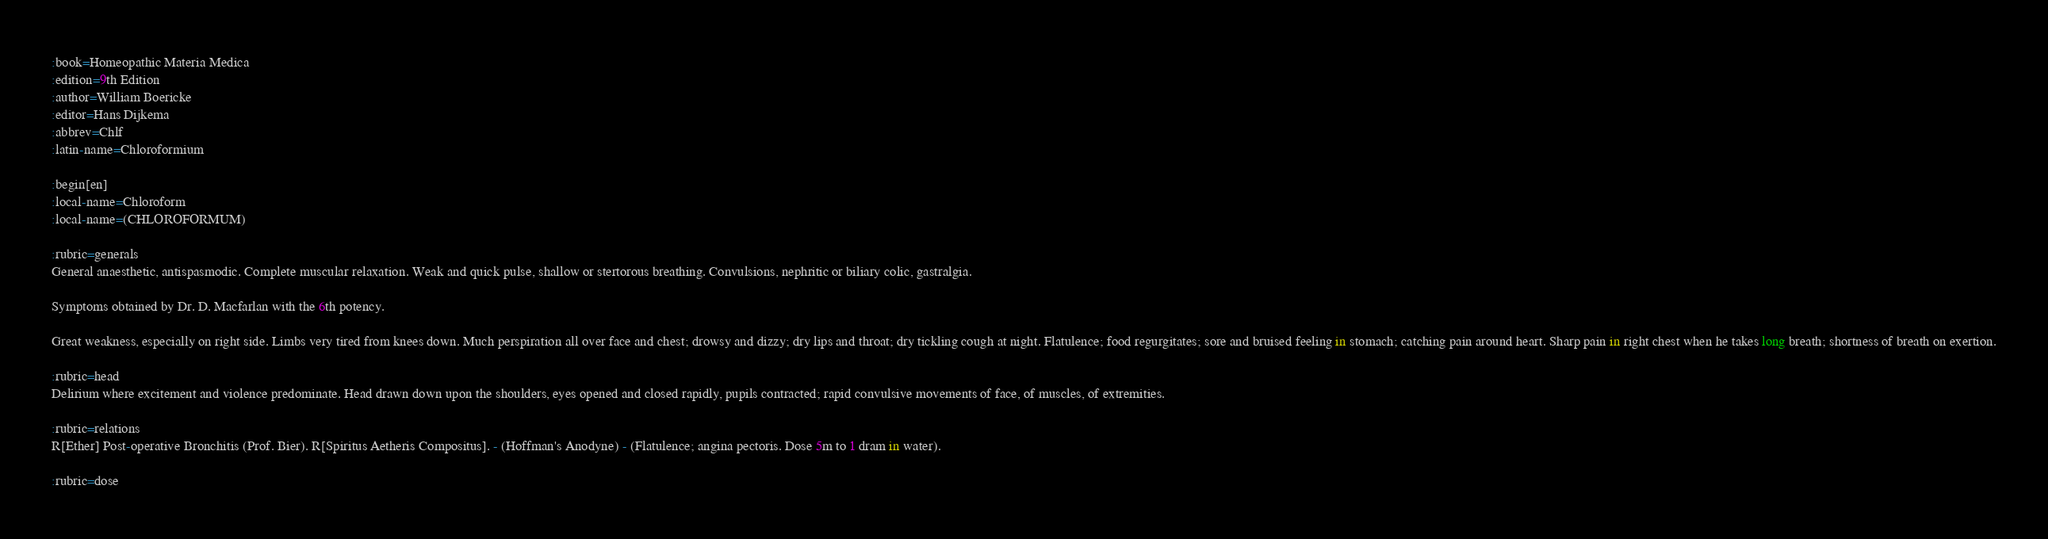<code> <loc_0><loc_0><loc_500><loc_500><_ObjectiveC_>:book=Homeopathic Materia Medica
:edition=9th Edition
:author=William Boericke
:editor=Hans Dijkema
:abbrev=Chlf
:latin-name=Chloroformium

:begin[en]
:local-name=Chloroform
:local-name=(CHLOROFORMUM)

:rubric=generals
General anaesthetic, antispasmodic. Complete muscular relaxation. Weak and quick pulse, shallow or stertorous breathing. Convulsions, nephritic or biliary colic, gastralgia.

Symptoms obtained by Dr. D. Macfarlan with the 6th potency.

Great weakness, especially on right side. Limbs very tired from knees down. Much perspiration all over face and chest; drowsy and dizzy; dry lips and throat; dry tickling cough at night. Flatulence; food regurgitates; sore and bruised feeling in stomach; catching pain around heart. Sharp pain in right chest when he takes long breath; shortness of breath on exertion.

:rubric=head
Delirium where excitement and violence predominate. Head drawn down upon the shoulders, eyes opened and closed rapidly, pupils contracted; rapid convulsive movements of face, of muscles, of extremities.

:rubric=relations
R[Ether] Post-operative Bronchitis (Prof. Bier). R[Spiritus Aetheris Compositus]. - (Hoffman's Anodyne) - (Flatulence; angina pectoris. Dose 5m to 1 dram in water).

:rubric=dose</code> 